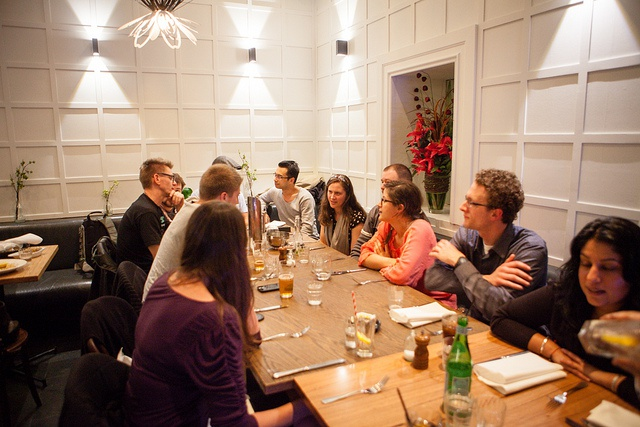Describe the objects in this image and their specific colors. I can see people in brown, black, maroon, and tan tones, dining table in brown, tan, and ivory tones, dining table in brown, orange, ivory, and tan tones, people in brown, black, and maroon tones, and people in brown, black, maroon, and gray tones in this image. 